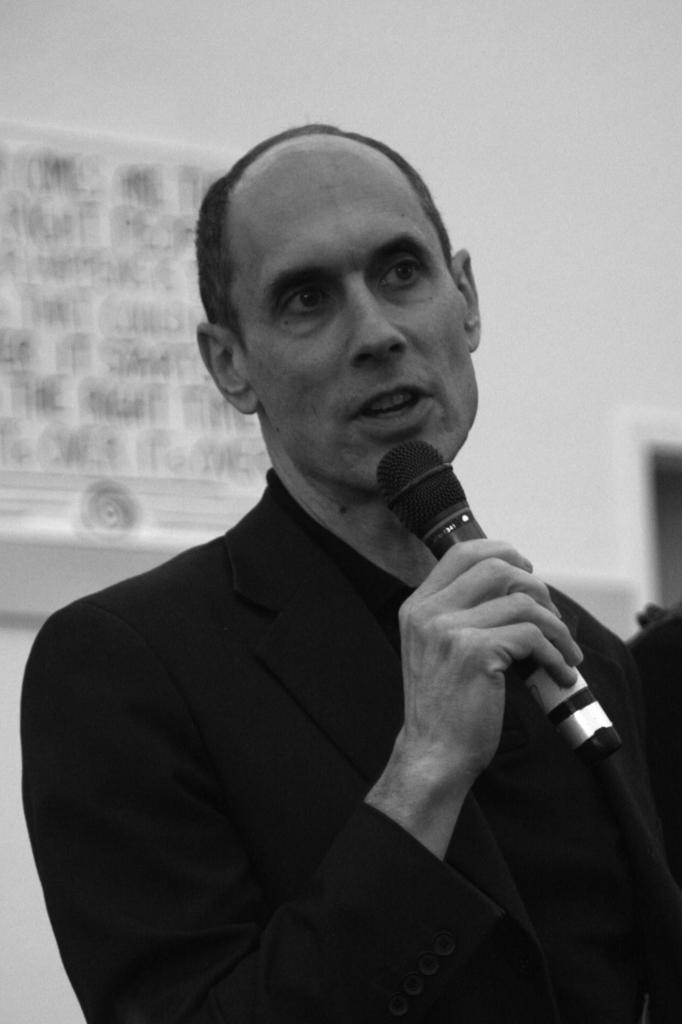In one or two sentences, can you explain what this image depicts? In this picture we can observe a man wearing a coat. He is holding a mic in his hand. In the background there is a wall. This is a black and white image. 